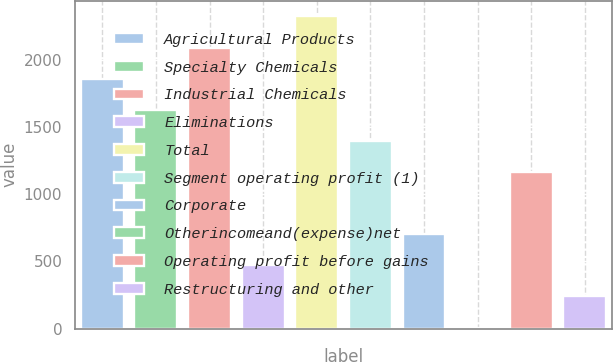Convert chart to OTSL. <chart><loc_0><loc_0><loc_500><loc_500><bar_chart><fcel>Agricultural Products<fcel>Specialty Chemicals<fcel>Industrial Chemicals<fcel>Eliminations<fcel>Total<fcel>Segment operating profit (1)<fcel>Corporate<fcel>Otherincomeand(expense)net<fcel>Operating profit before gains<fcel>Restructuring and other<nl><fcel>1858.26<fcel>1627.14<fcel>2089.38<fcel>471.54<fcel>2320.5<fcel>1396.02<fcel>702.66<fcel>9.3<fcel>1164.9<fcel>240.42<nl></chart> 